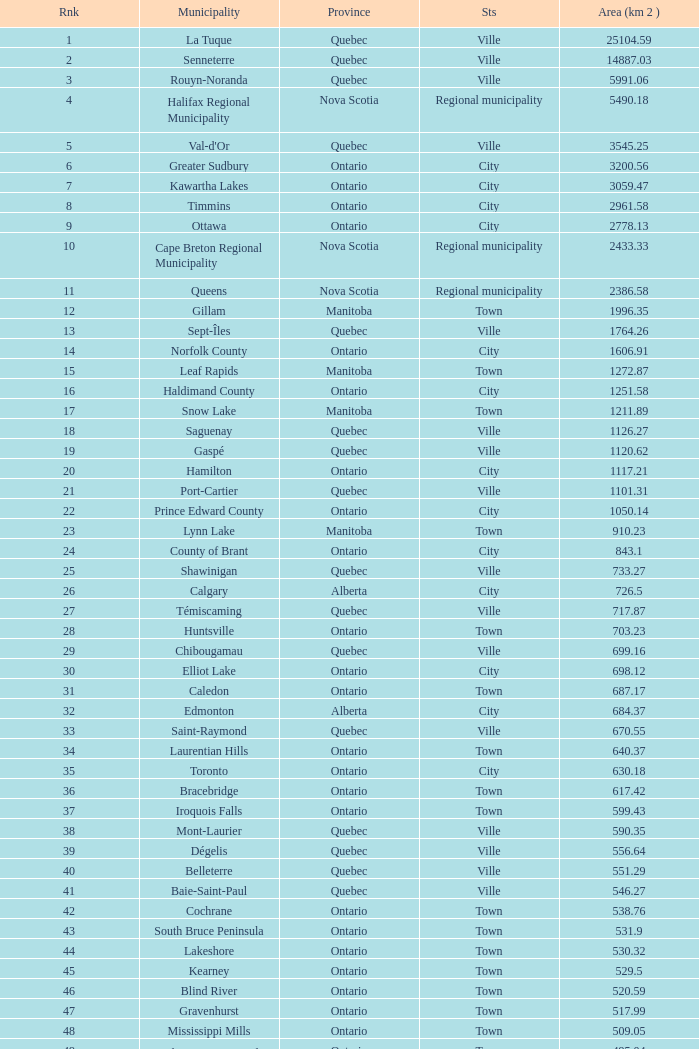Could you help me parse every detail presented in this table? {'header': ['Rnk', 'Municipality', 'Province', 'Sts', 'Area (km 2 )'], 'rows': [['1', 'La Tuque', 'Quebec', 'Ville', '25104.59'], ['2', 'Senneterre', 'Quebec', 'Ville', '14887.03'], ['3', 'Rouyn-Noranda', 'Quebec', 'Ville', '5991.06'], ['4', 'Halifax Regional Municipality', 'Nova Scotia', 'Regional municipality', '5490.18'], ['5', "Val-d'Or", 'Quebec', 'Ville', '3545.25'], ['6', 'Greater Sudbury', 'Ontario', 'City', '3200.56'], ['7', 'Kawartha Lakes', 'Ontario', 'City', '3059.47'], ['8', 'Timmins', 'Ontario', 'City', '2961.58'], ['9', 'Ottawa', 'Ontario', 'City', '2778.13'], ['10', 'Cape Breton Regional Municipality', 'Nova Scotia', 'Regional municipality', '2433.33'], ['11', 'Queens', 'Nova Scotia', 'Regional municipality', '2386.58'], ['12', 'Gillam', 'Manitoba', 'Town', '1996.35'], ['13', 'Sept-Îles', 'Quebec', 'Ville', '1764.26'], ['14', 'Norfolk County', 'Ontario', 'City', '1606.91'], ['15', 'Leaf Rapids', 'Manitoba', 'Town', '1272.87'], ['16', 'Haldimand County', 'Ontario', 'City', '1251.58'], ['17', 'Snow Lake', 'Manitoba', 'Town', '1211.89'], ['18', 'Saguenay', 'Quebec', 'Ville', '1126.27'], ['19', 'Gaspé', 'Quebec', 'Ville', '1120.62'], ['20', 'Hamilton', 'Ontario', 'City', '1117.21'], ['21', 'Port-Cartier', 'Quebec', 'Ville', '1101.31'], ['22', 'Prince Edward County', 'Ontario', 'City', '1050.14'], ['23', 'Lynn Lake', 'Manitoba', 'Town', '910.23'], ['24', 'County of Brant', 'Ontario', 'City', '843.1'], ['25', 'Shawinigan', 'Quebec', 'Ville', '733.27'], ['26', 'Calgary', 'Alberta', 'City', '726.5'], ['27', 'Témiscaming', 'Quebec', 'Ville', '717.87'], ['28', 'Huntsville', 'Ontario', 'Town', '703.23'], ['29', 'Chibougamau', 'Quebec', 'Ville', '699.16'], ['30', 'Elliot Lake', 'Ontario', 'City', '698.12'], ['31', 'Caledon', 'Ontario', 'Town', '687.17'], ['32', 'Edmonton', 'Alberta', 'City', '684.37'], ['33', 'Saint-Raymond', 'Quebec', 'Ville', '670.55'], ['34', 'Laurentian Hills', 'Ontario', 'Town', '640.37'], ['35', 'Toronto', 'Ontario', 'City', '630.18'], ['36', 'Bracebridge', 'Ontario', 'Town', '617.42'], ['37', 'Iroquois Falls', 'Ontario', 'Town', '599.43'], ['38', 'Mont-Laurier', 'Quebec', 'Ville', '590.35'], ['39', 'Dégelis', 'Quebec', 'Ville', '556.64'], ['40', 'Belleterre', 'Quebec', 'Ville', '551.29'], ['41', 'Baie-Saint-Paul', 'Quebec', 'Ville', '546.27'], ['42', 'Cochrane', 'Ontario', 'Town', '538.76'], ['43', 'South Bruce Peninsula', 'Ontario', 'Town', '531.9'], ['44', 'Lakeshore', 'Ontario', 'Town', '530.32'], ['45', 'Kearney', 'Ontario', 'Town', '529.5'], ['46', 'Blind River', 'Ontario', 'Town', '520.59'], ['47', 'Gravenhurst', 'Ontario', 'Town', '517.99'], ['48', 'Mississippi Mills', 'Ontario', 'Town', '509.05'], ['49', 'Northeastern Manitoulin and the Islands', 'Ontario', 'Town', '495.04'], ['50', 'Quinte West', 'Ontario', 'City', '493.85'], ['51', 'Mirabel', 'Quebec', 'Ville', '485.51'], ['52', 'Fermont', 'Quebec', 'Ville', '470.67'], ['53', 'Winnipeg', 'Manitoba', 'City', '464.01'], ['54', 'Greater Napanee', 'Ontario', 'Town', '459.71'], ['55', 'La Malbaie', 'Quebec', 'Ville', '459.34'], ['56', 'Rivière-Rouge', 'Quebec', 'Ville', '454.99'], ['57', 'Québec City', 'Quebec', 'Ville', '454.26'], ['58', 'Kingston', 'Ontario', 'City', '450.39'], ['59', 'Lévis', 'Quebec', 'Ville', '449.32'], ['60', "St. John's", 'Newfoundland and Labrador', 'City', '446.04'], ['61', 'Bécancour', 'Quebec', 'Ville', '441'], ['62', 'Percé', 'Quebec', 'Ville', '432.39'], ['63', 'Amos', 'Quebec', 'Ville', '430.06'], ['64', 'London', 'Ontario', 'City', '420.57'], ['65', 'Chandler', 'Quebec', 'Ville', '419.5'], ['66', 'Whitehorse', 'Yukon', 'City', '416.43'], ['67', 'Gracefield', 'Quebec', 'Ville', '386.21'], ['68', 'Baie Verte', 'Newfoundland and Labrador', 'Town', '371.07'], ['69', 'Milton', 'Ontario', 'Town', '366.61'], ['70', 'Montreal', 'Quebec', 'Ville', '365.13'], ['71', 'Saint-Félicien', 'Quebec', 'Ville', '363.57'], ['72', 'Abbotsford', 'British Columbia', 'City', '359.36'], ['73', 'Sherbrooke', 'Quebec', 'Ville', '353.46'], ['74', 'Gatineau', 'Quebec', 'Ville', '342.32'], ['75', 'Pohénégamook', 'Quebec', 'Ville', '340.33'], ['76', 'Baie-Comeau', 'Quebec', 'Ville', '338.88'], ['77', 'Thunder Bay', 'Ontario', 'City', '328.48'], ['78', 'Plympton–Wyoming', 'Ontario', 'Town', '318.76'], ['79', 'Surrey', 'British Columbia', 'City', '317.19'], ['80', 'Prince George', 'British Columbia', 'City', '316'], ['81', 'Saint John', 'New Brunswick', 'City', '315.49'], ['82', 'North Bay', 'Ontario', 'City', '314.91'], ['83', 'Happy Valley-Goose Bay', 'Newfoundland and Labrador', 'Town', '305.85'], ['84', 'Minto', 'Ontario', 'Town', '300.37'], ['85', 'Kamloops', 'British Columbia', 'City', '297.3'], ['86', 'Erin', 'Ontario', 'Town', '296.98'], ['87', 'Clarence-Rockland', 'Ontario', 'City', '296.53'], ['88', 'Cookshire-Eaton', 'Quebec', 'Ville', '295.93'], ['89', 'Dolbeau-Mistassini', 'Quebec', 'Ville', '295.67'], ['90', 'Trois-Rivières', 'Quebec', 'Ville', '288.92'], ['91', 'Mississauga', 'Ontario', 'City', '288.53'], ['92', 'Georgina', 'Ontario', 'Town', '287.72'], ['93', 'The Blue Mountains', 'Ontario', 'Town', '286.78'], ['94', 'Innisfil', 'Ontario', 'Town', '284.18'], ['95', 'Essex', 'Ontario', 'Town', '277.95'], ['96', 'Mono', 'Ontario', 'Town', '277.67'], ['97', 'Halton Hills', 'Ontario', 'Town', '276.26'], ['98', 'New Tecumseth', 'Ontario', 'Town', '274.18'], ['99', 'Vaughan', 'Ontario', 'City', '273.58'], ['100', 'Brampton', 'Ontario', 'City', '266.71']]} What Municipality has a Rank of 44? Lakeshore. 